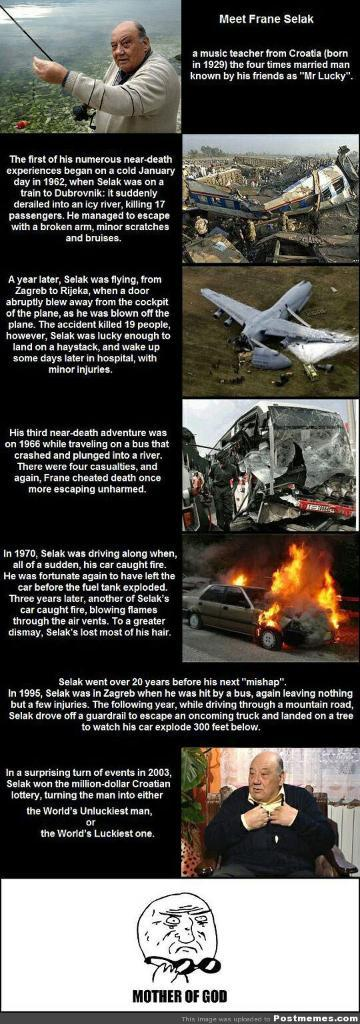<image>
Render a clear and concise summary of the photo. a flyer says Meet Frane Selak and has other pictures on it 